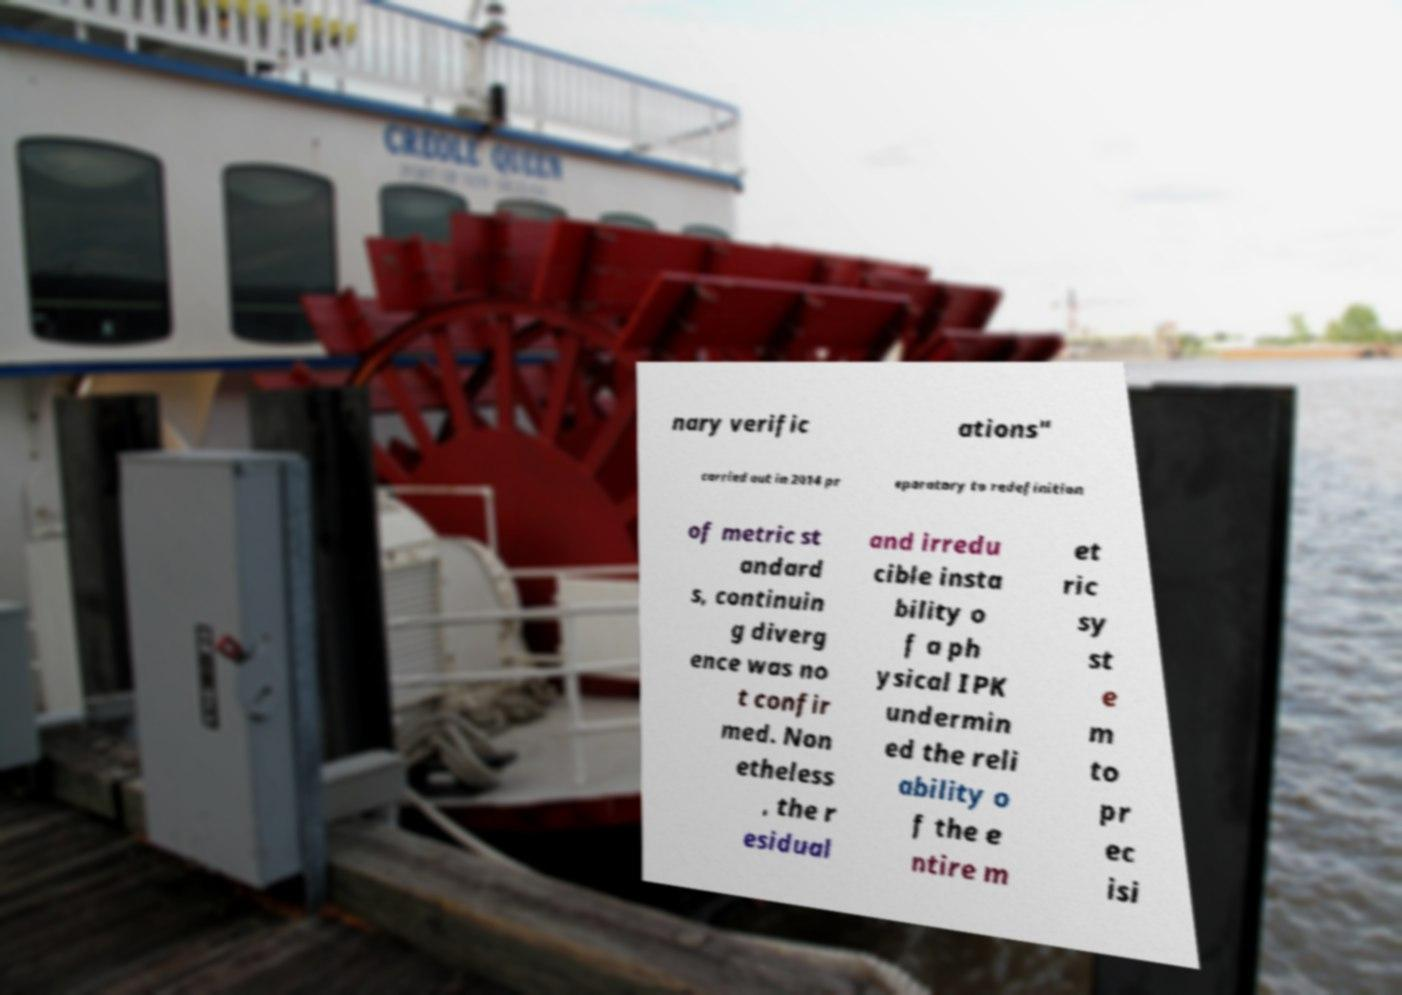Please identify and transcribe the text found in this image. nary verific ations" carried out in 2014 pr eparatory to redefinition of metric st andard s, continuin g diverg ence was no t confir med. Non etheless , the r esidual and irredu cible insta bility o f a ph ysical IPK undermin ed the reli ability o f the e ntire m et ric sy st e m to pr ec isi 